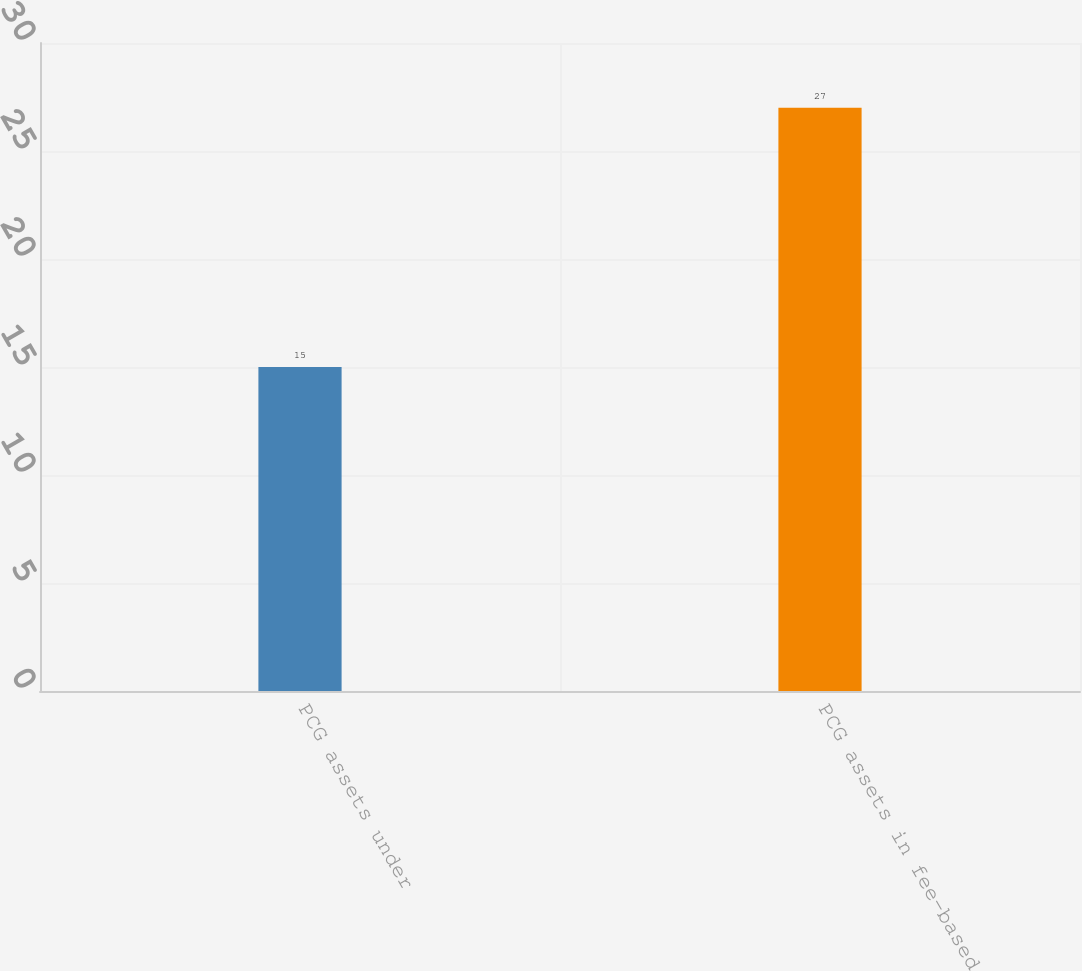Convert chart to OTSL. <chart><loc_0><loc_0><loc_500><loc_500><bar_chart><fcel>PCG assets under<fcel>PCG assets in fee-based<nl><fcel>15<fcel>27<nl></chart> 